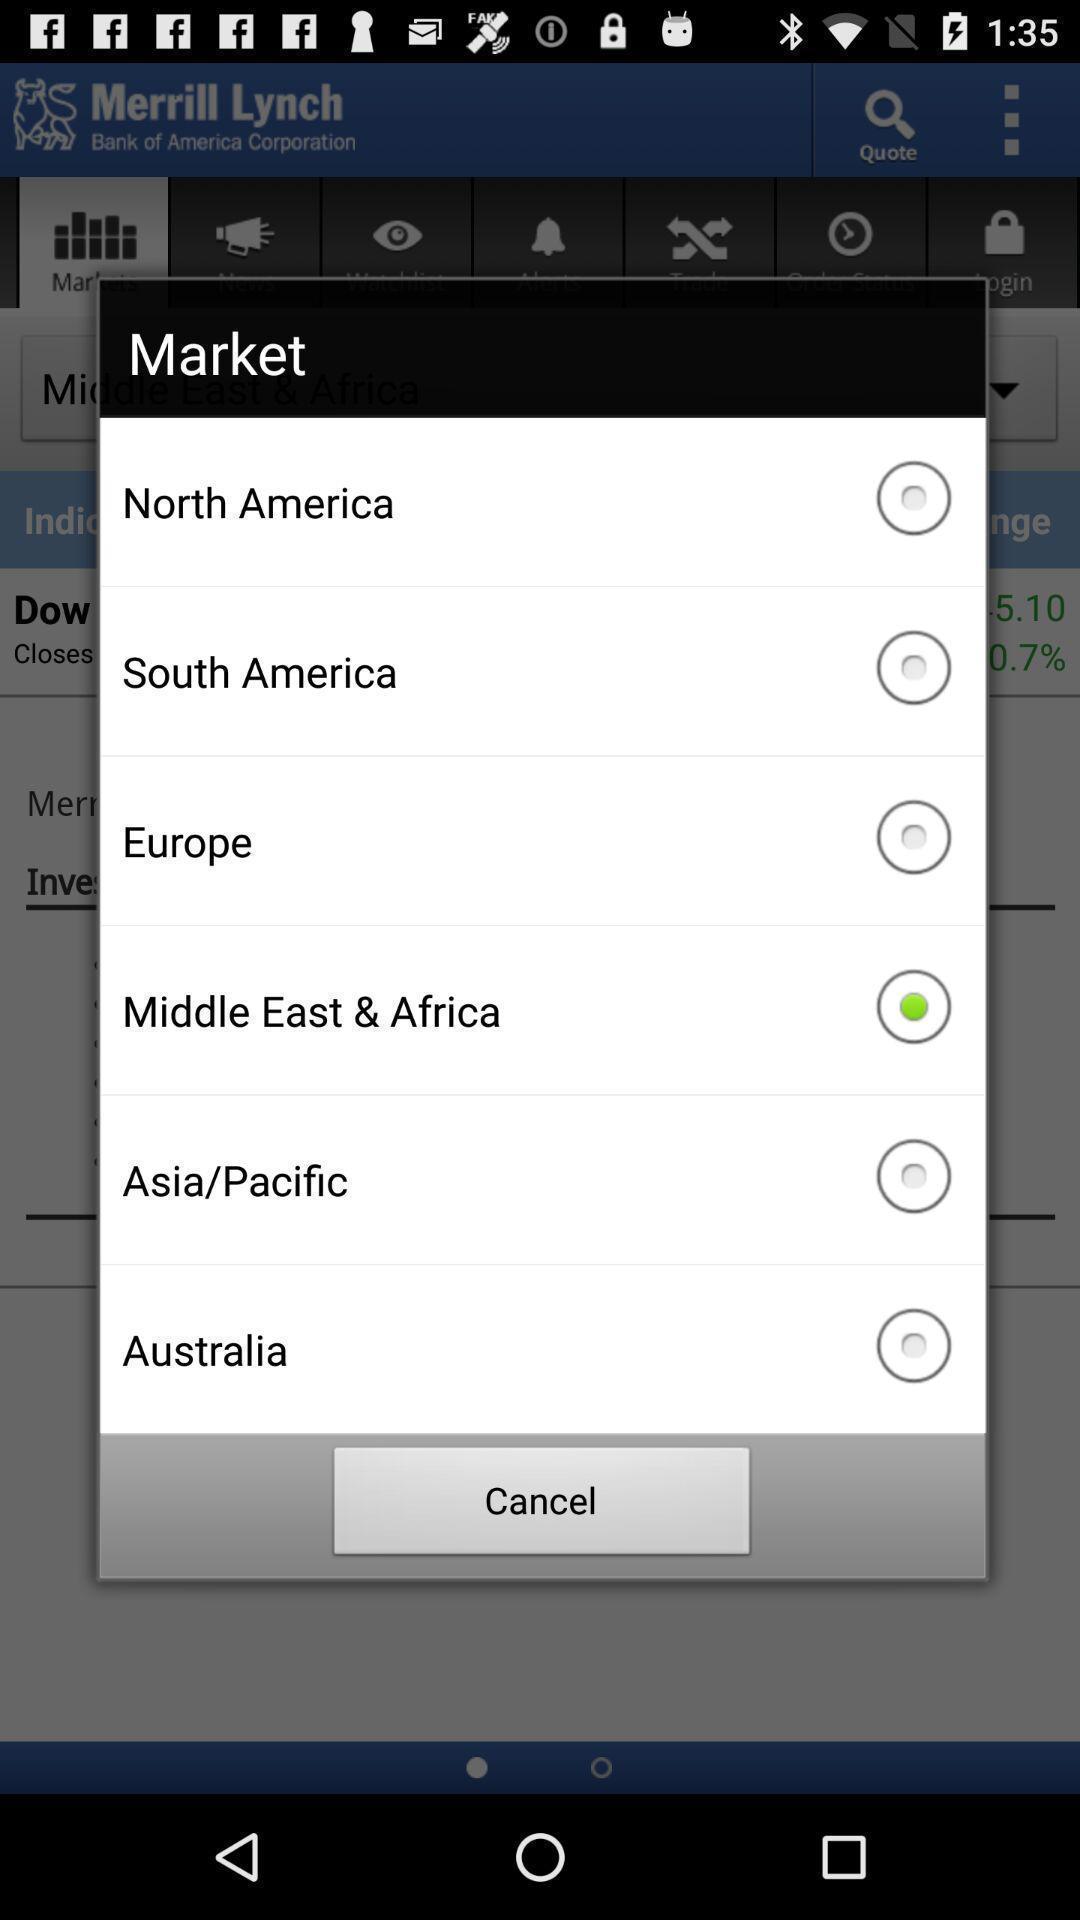Tell me what you see in this picture. Pop-up page displaying with different location options. 